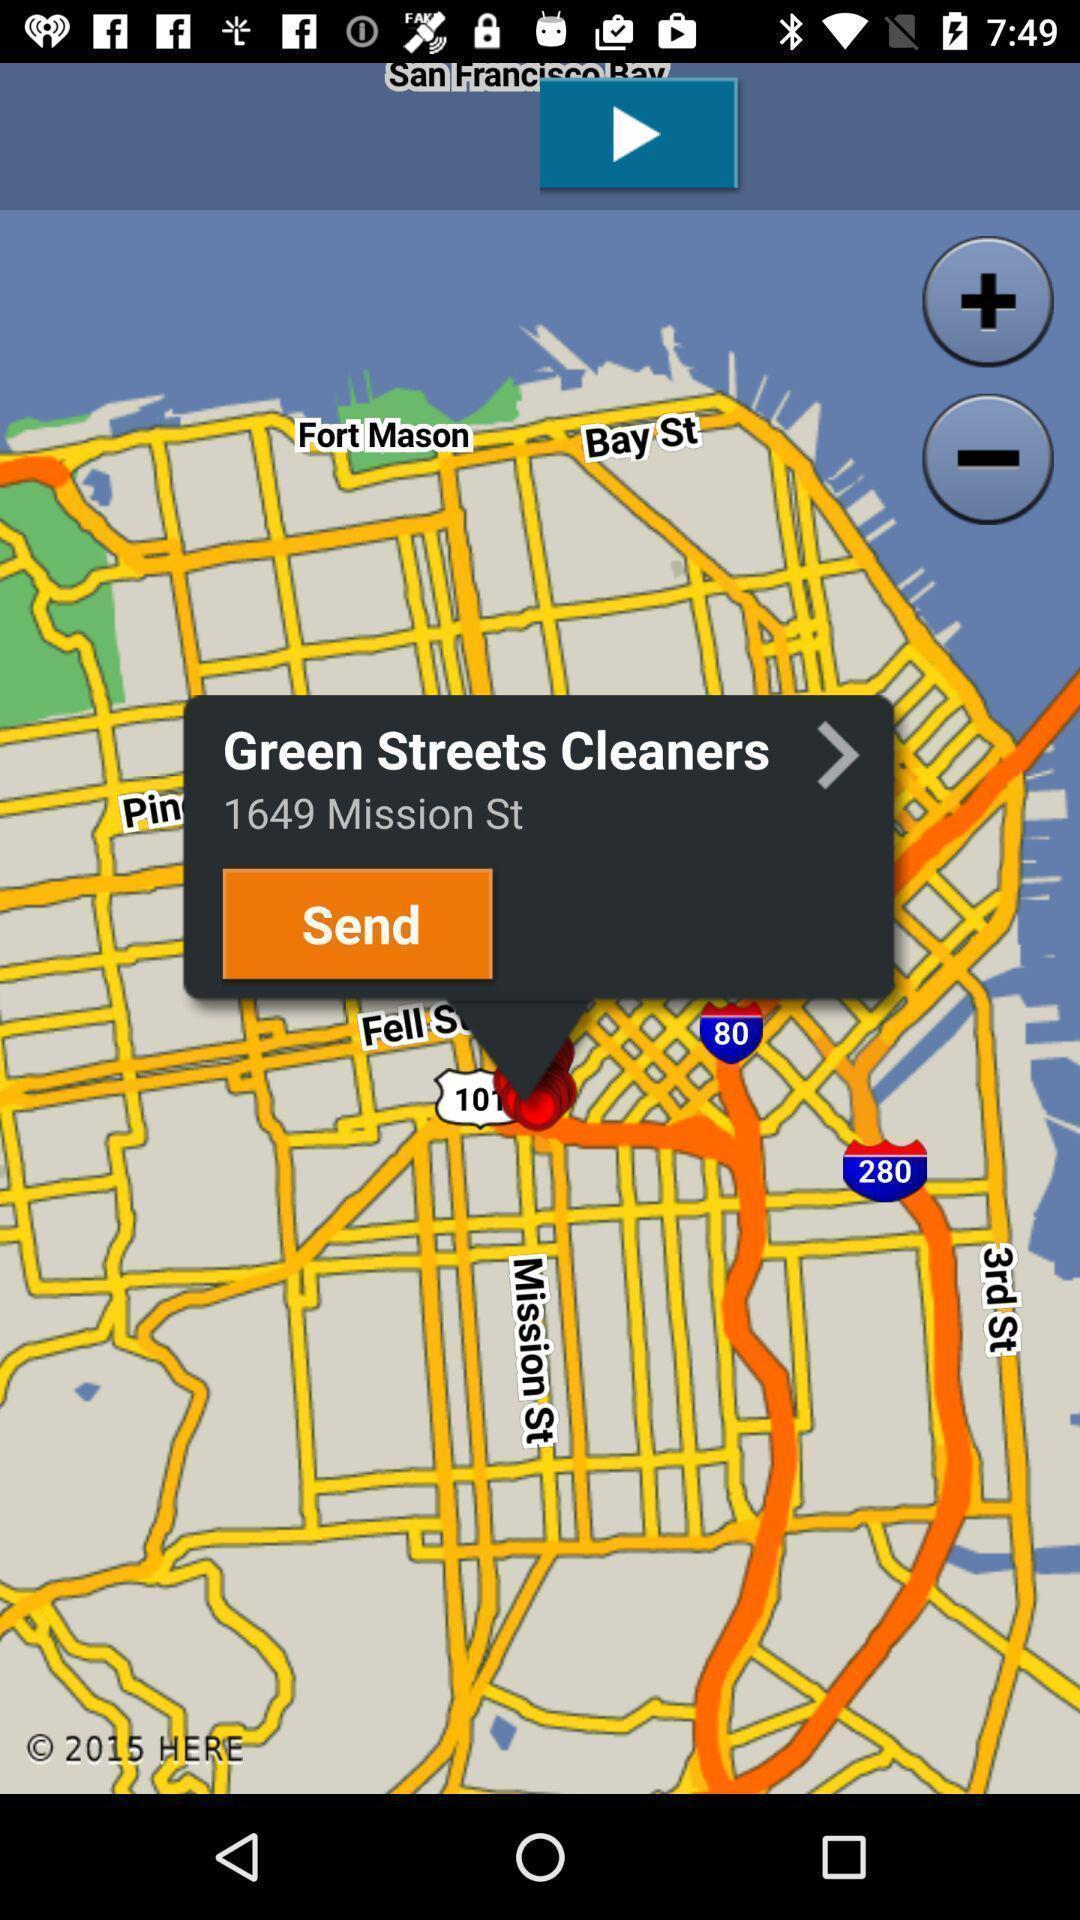Explain what's happening in this screen capture. Popup displaying an address in navigation app. 